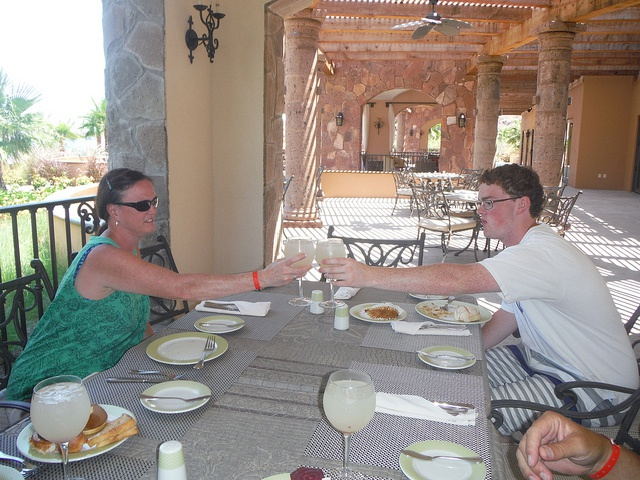Describe the objects in this image and their specific colors. I can see dining table in white, darkgray, gray, and lightgray tones, people in white, darkgray, lightgray, and gray tones, people in white, teal, gray, and darkgray tones, people in white, gray, darkgray, and maroon tones, and chair in white, black, gray, and teal tones in this image. 